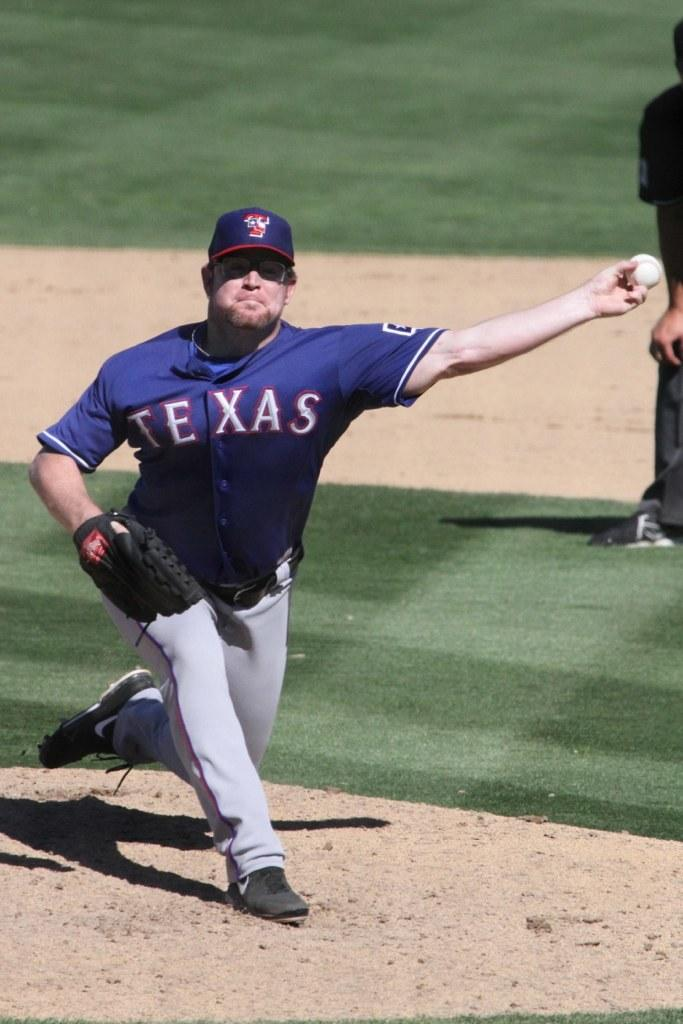<image>
Provide a brief description of the given image. A man holding a ball that is wearing a baseball jersey that says Texas. 